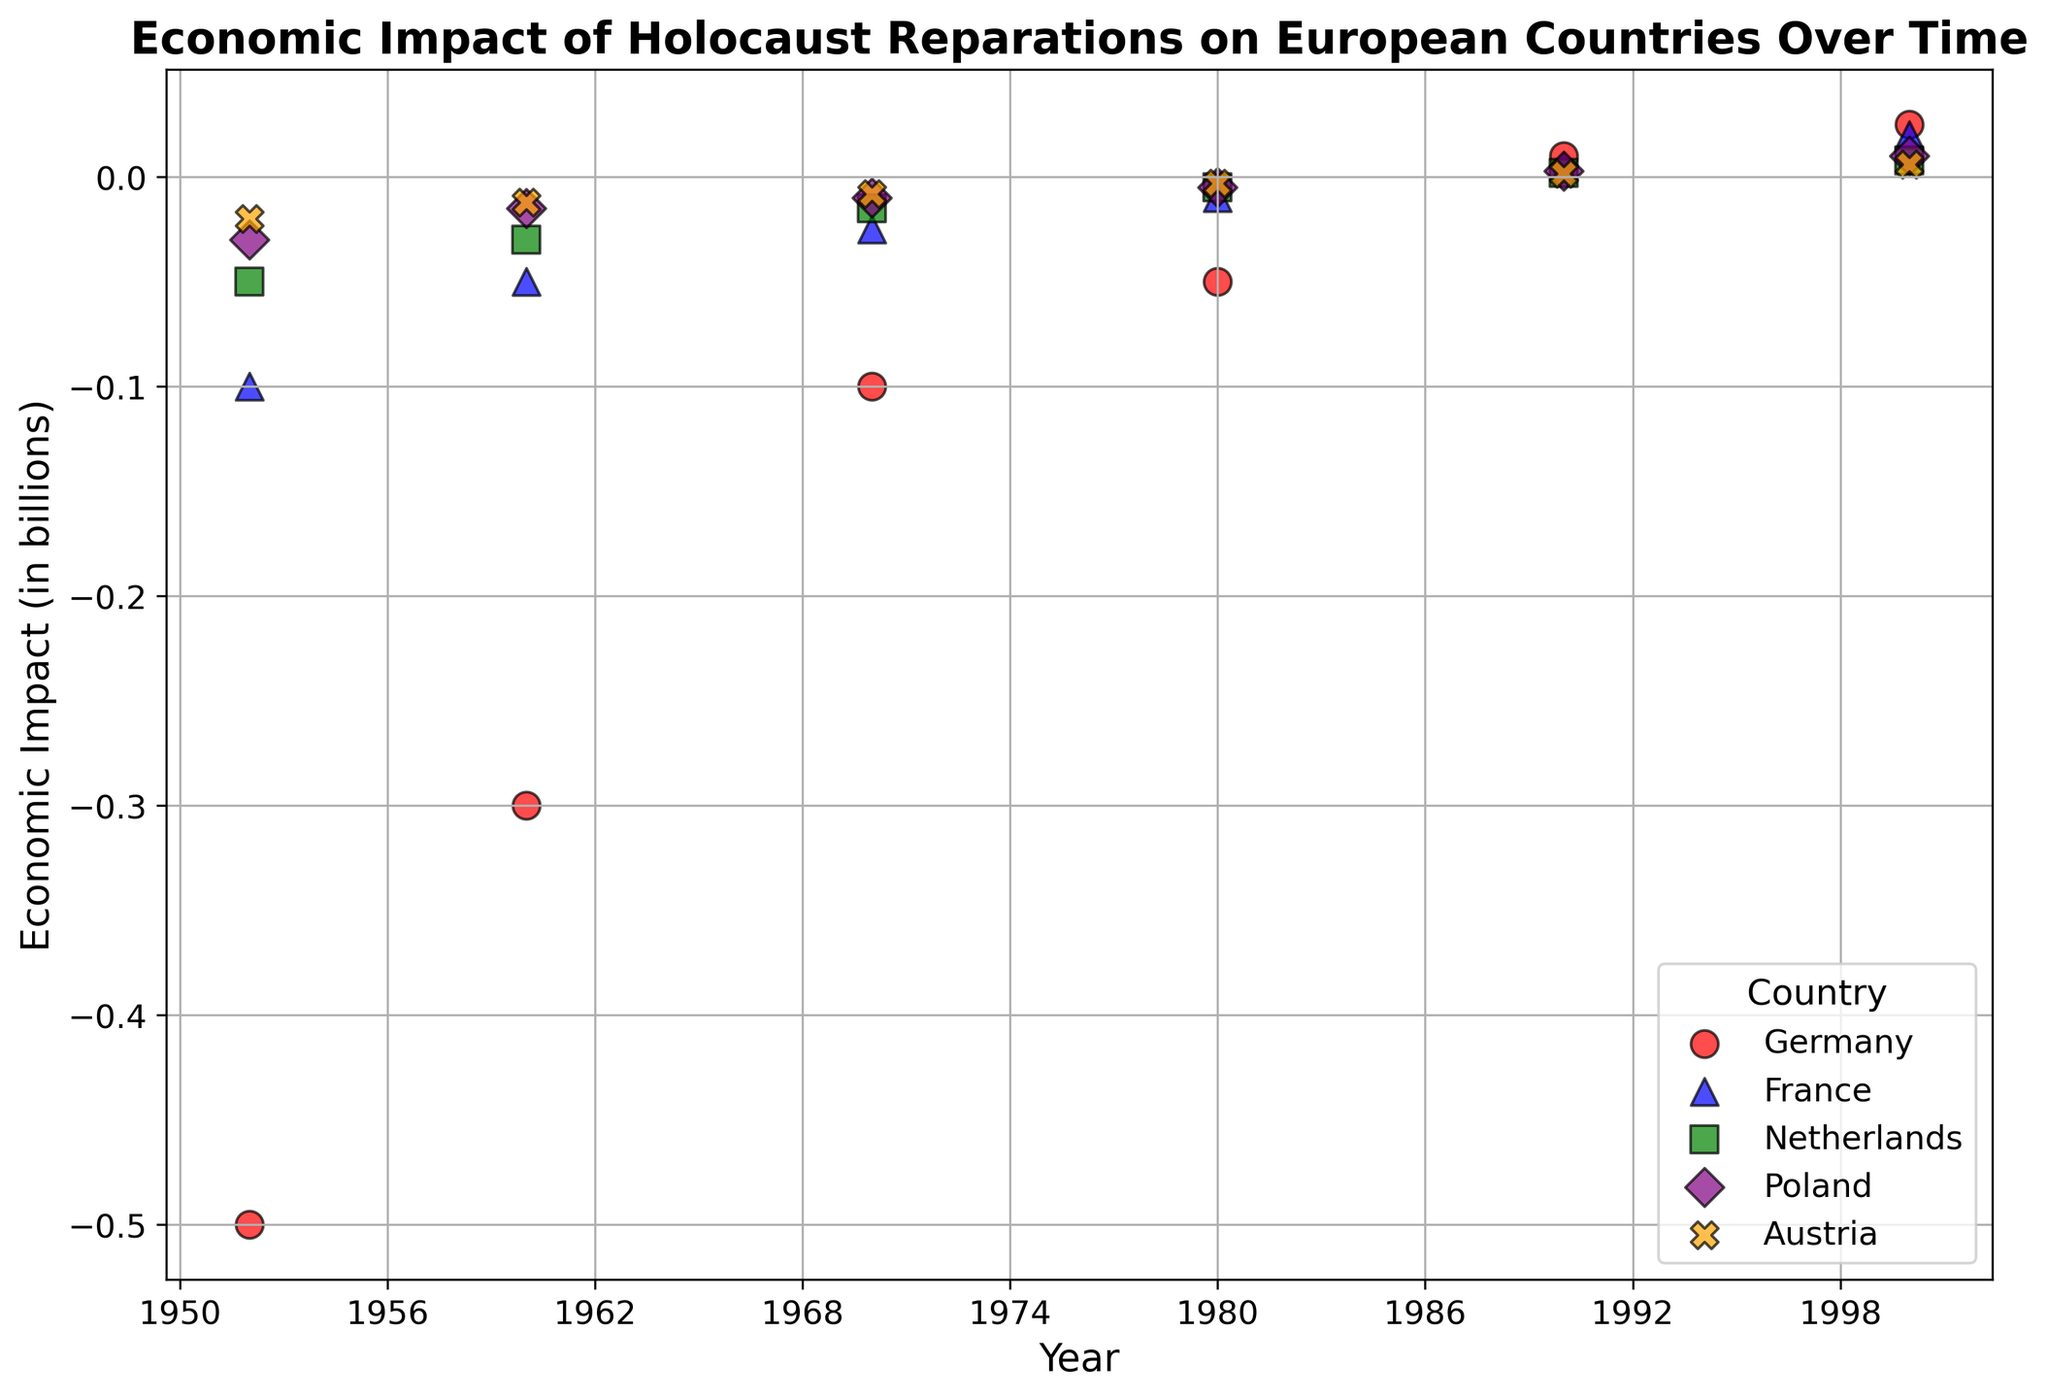Which country experienced the highest economic impact in 2000? By looking at the scatter plot, identify the mark representing the highest economic impact value in the year 2000. It shows an upward trend for each country, and Germany, shown in red, has the highest value.
Answer: Germany Did Austria have a positive economic impact in the year 1990? Locate the point for Austria (orange 'X' marker) in the year 1990 on the x-axis. If the corresponding y-value mark is above zero, the impact is positive. The data shows it is indeed positive.
Answer: Yes How did Germany's economic impact change from 1952 to 2000? For Germany (red circles), note the y-values from 1952 to 2000. The value started negatively at -500,000,000 in 1952 and became positive at 25,000,000 in 2000. This indicates an overall increase.
Answer: Increased Which country had the smallest economic loss in the year 1952, and what was the value? Compare the y-values of all countries for the year 1952 on the plot, finding the highest value (least negative). Austria, represented by the orange 'X', shows the smallest loss at -20,000,000.
Answer: Austria, -20,000,000 What is the difference in economic impact between 1960 and 1980 for France? Find France (blue triangles) for the years 1960 and 1980. The economic impact values are -50,000,000 in 1960 and -10,000,000 in 1980. The difference is -50,000,000 - (-10,000,000) = -40,000,000.
Answer: -40,000,000 Which two countries had positive economic impacts in 2000, and what were the values? Examine the y-values for all countries in 2000 and locate those above zero. Germany (red circles) and France (blue triangles) both have positive impacts, with values of 25,000,000 and 20,000,000, respectively.
Answer: Germany: 25,000,000; France: 20,000,000 What is the average economic impact for the Netherlands in 1970, 1980, and 1990? Look for the y-values for the Netherlands (green squares) in the specified years: -15,000,000 in 1970, -5,000,000 in 1980, and 2,000,000 in 1990. The average is calculated as (-15,000,000 + (-5,000,000) + 2,000,000) / 3 = -6,000,000 / 3 = -6,000,000.
Answer: -6,000,000 How did Poland's economic impact change from 1960 to 1990? For Poland (purple diamonds), note economic values in 1960 and 1990. From a loss of -15,000,000 in 1960, it shifts to a gain of 3,000,000 in 1990. This marks an increase.
Answer: Increased Which country's economic impact remained consistently negative until 1980? Check each country's trajectory up to 1980 to find consistently negative values. Germany, France, the Netherlands, Poland, and Austria show this pattern until 1980.
Answer: All countries 